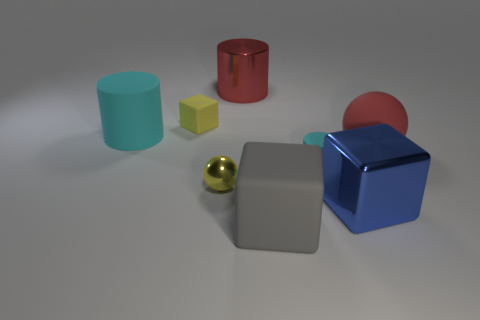The cylinder that is made of the same material as the tiny cyan object is what size?
Your answer should be very brief. Large. What material is the big ball?
Provide a short and direct response. Rubber. How many red rubber spheres have the same size as the yellow rubber thing?
Provide a short and direct response. 0. There is a metallic thing that is the same color as the rubber sphere; what is its shape?
Offer a terse response. Cylinder. Are there any big blue objects that have the same shape as the tiny cyan thing?
Offer a very short reply. No. What color is the cylinder that is the same size as the yellow ball?
Offer a terse response. Cyan. There is a cylinder that is behind the tiny yellow thing behind the metallic sphere; what color is it?
Give a very brief answer. Red. There is a rubber cylinder that is to the left of the gray block; is its color the same as the tiny shiny ball?
Provide a succinct answer. No. What is the shape of the big metal thing that is behind the metallic thing that is to the right of the cyan cylinder that is right of the large red metal object?
Ensure brevity in your answer.  Cylinder. What number of big blue objects are on the left side of the cyan cylinder that is left of the tiny yellow ball?
Ensure brevity in your answer.  0. 